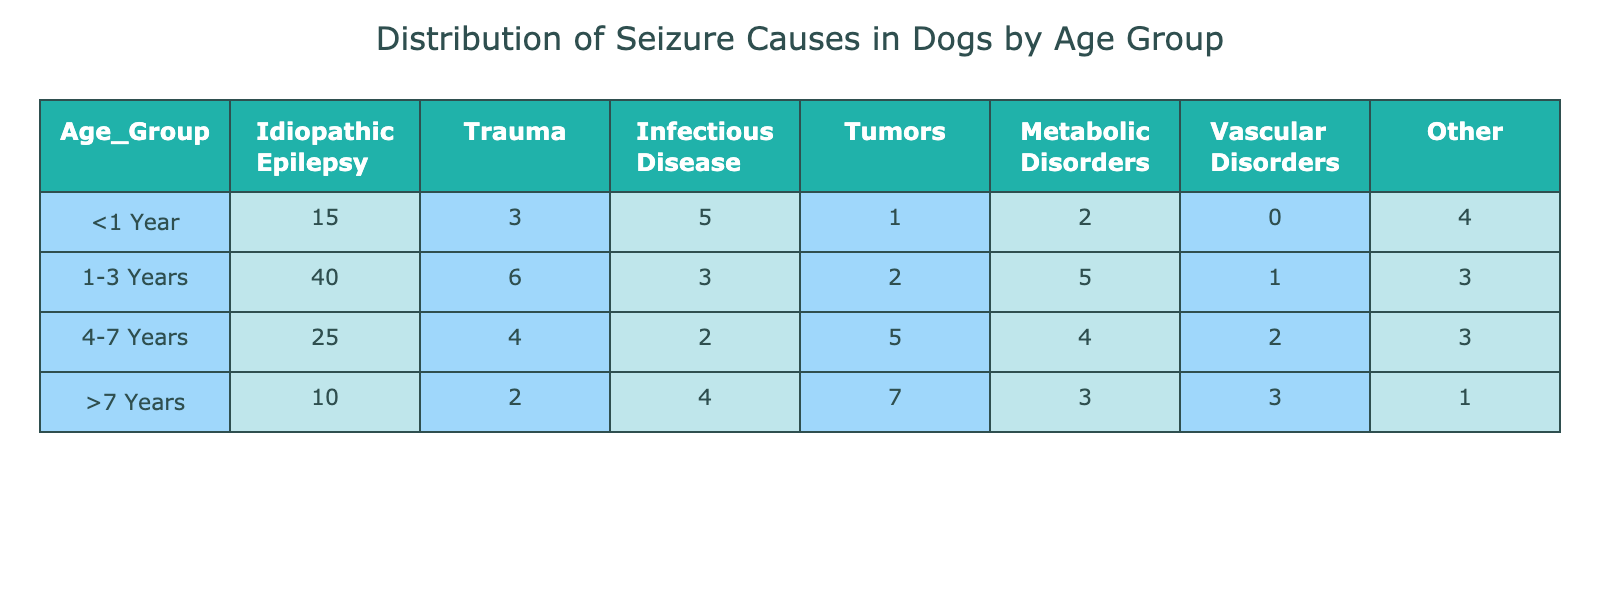What is the total number of seizures attributed to Idiopathic Epilepsy in dogs aged 1-3 years? From the table, the number of seizures attributed to Idiopathic Epilepsy in the 1-3 years age group is 40.
Answer: 40 How many cases of trauma were reported in dogs over 7 years old? According to the table, in the >7 Years age group, the count of trauma cases is 2.
Answer: 2 What is the total number of seizures caused by tumors across all age groups? To find the total, sum the cases of tumors from each age group: (1 + 2 + 5 + 7) = 15.
Answer: 15 In which age group do we see the highest number of metabolic disorders? The highest count of metabolic disorders is found in the 1-3 years age group with 5 cases.
Answer: 1-3 Years Are there more cases of infectious disease in dogs <1 year than in dogs 4-7 years? Dogs <1 year have 5 cases of infectious disease, while dogs in the 4-7 years age group have only 2 cases, which confirms that there are more cases in the younger age group.
Answer: Yes What is the difference in the number of 'Other' seizure causes between dogs aged 1-3 years and dogs aged >7 years? For the 1-3 years age group, there are 3 cases of 'Other', whereas in the >7 years group there is 1 case. The difference is 3 - 1 = 2.
Answer: 2 What is the average number of seizure causes across all age groups for trauma? To find the average for trauma, sum the cases (3 + 6 + 4 + 2 = 15) and divide by the number of age groups (4): 15 / 4 = 3.75.
Answer: 3.75 Which seizure cause has the highest total number across all age groups, and what is that number? Summing the counts for each cause: Idiopathic Epilepsy (90), Trauma (15), Infectious Disease (14), Tumors (15), Metabolic (14), Vascular (6), Other (11). The highest is Idiopathic Epilepsy with 90 cases.
Answer: Idiopathic Epilepsy, 90 How many dogs aged 4-7 years experienced vascular disorders? In the age group 4-7 years, 2 cases of vascular disorders were reported according to the table.
Answer: 2 